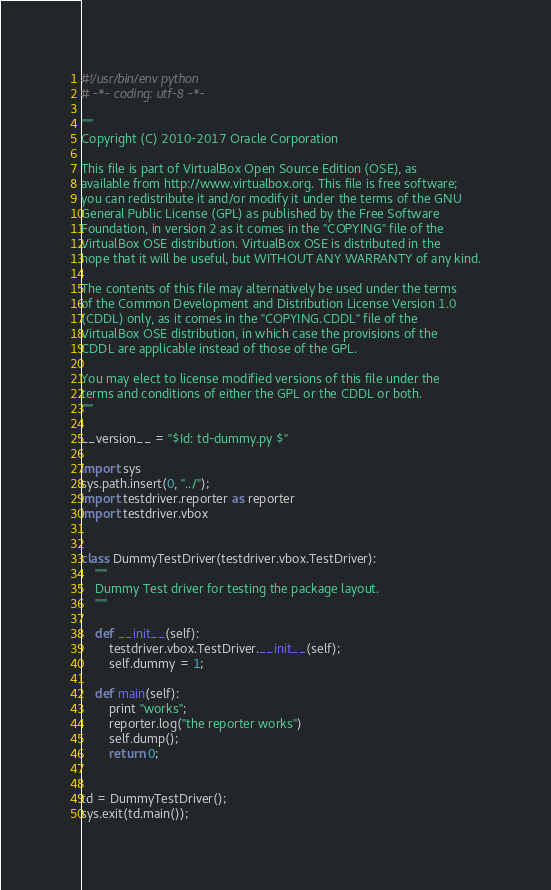Convert code to text. <code><loc_0><loc_0><loc_500><loc_500><_Python_>#!/usr/bin/env python
# -*- coding: utf-8 -*-

"""
Copyright (C) 2010-2017 Oracle Corporation

This file is part of VirtualBox Open Source Edition (OSE), as
available from http://www.virtualbox.org. This file is free software;
you can redistribute it and/or modify it under the terms of the GNU
General Public License (GPL) as published by the Free Software
Foundation, in version 2 as it comes in the "COPYING" file of the
VirtualBox OSE distribution. VirtualBox OSE is distributed in the
hope that it will be useful, but WITHOUT ANY WARRANTY of any kind.

The contents of this file may alternatively be used under the terms
of the Common Development and Distribution License Version 1.0
(CDDL) only, as it comes in the "COPYING.CDDL" file of the
VirtualBox OSE distribution, in which case the provisions of the
CDDL are applicable instead of those of the GPL.

You may elect to license modified versions of this file under the
terms and conditions of either the GPL or the CDDL or both.
"""

__version__ = "$Id: td-dummy.py $"

import sys
sys.path.insert(0, "../");
import testdriver.reporter as reporter
import testdriver.vbox


class DummyTestDriver(testdriver.vbox.TestDriver):
    """
    Dummy Test driver for testing the package layout.
    """

    def __init__(self):
        testdriver.vbox.TestDriver.__init__(self);
        self.dummy = 1;

    def main(self):
        print "works";
        reporter.log("the reporter works")
        self.dump();
        return 0;


td = DummyTestDriver();
sys.exit(td.main());

</code> 